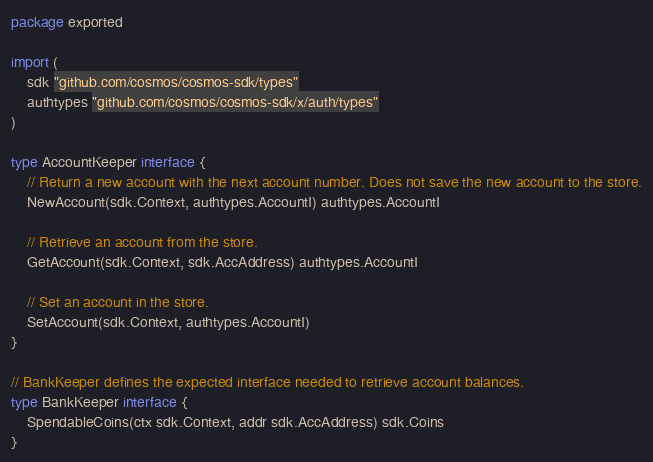<code> <loc_0><loc_0><loc_500><loc_500><_Go_>package exported

import (
	sdk "github.com/cosmos/cosmos-sdk/types"
	authtypes "github.com/cosmos/cosmos-sdk/x/auth/types"
)

type AccountKeeper interface {
	// Return a new account with the next account number. Does not save the new account to the store.
	NewAccount(sdk.Context, authtypes.AccountI) authtypes.AccountI

	// Retrieve an account from the store.
	GetAccount(sdk.Context, sdk.AccAddress) authtypes.AccountI

	// Set an account in the store.
	SetAccount(sdk.Context, authtypes.AccountI)
}

// BankKeeper defines the expected interface needed to retrieve account balances.
type BankKeeper interface {
	SpendableCoins(ctx sdk.Context, addr sdk.AccAddress) sdk.Coins
}
</code> 